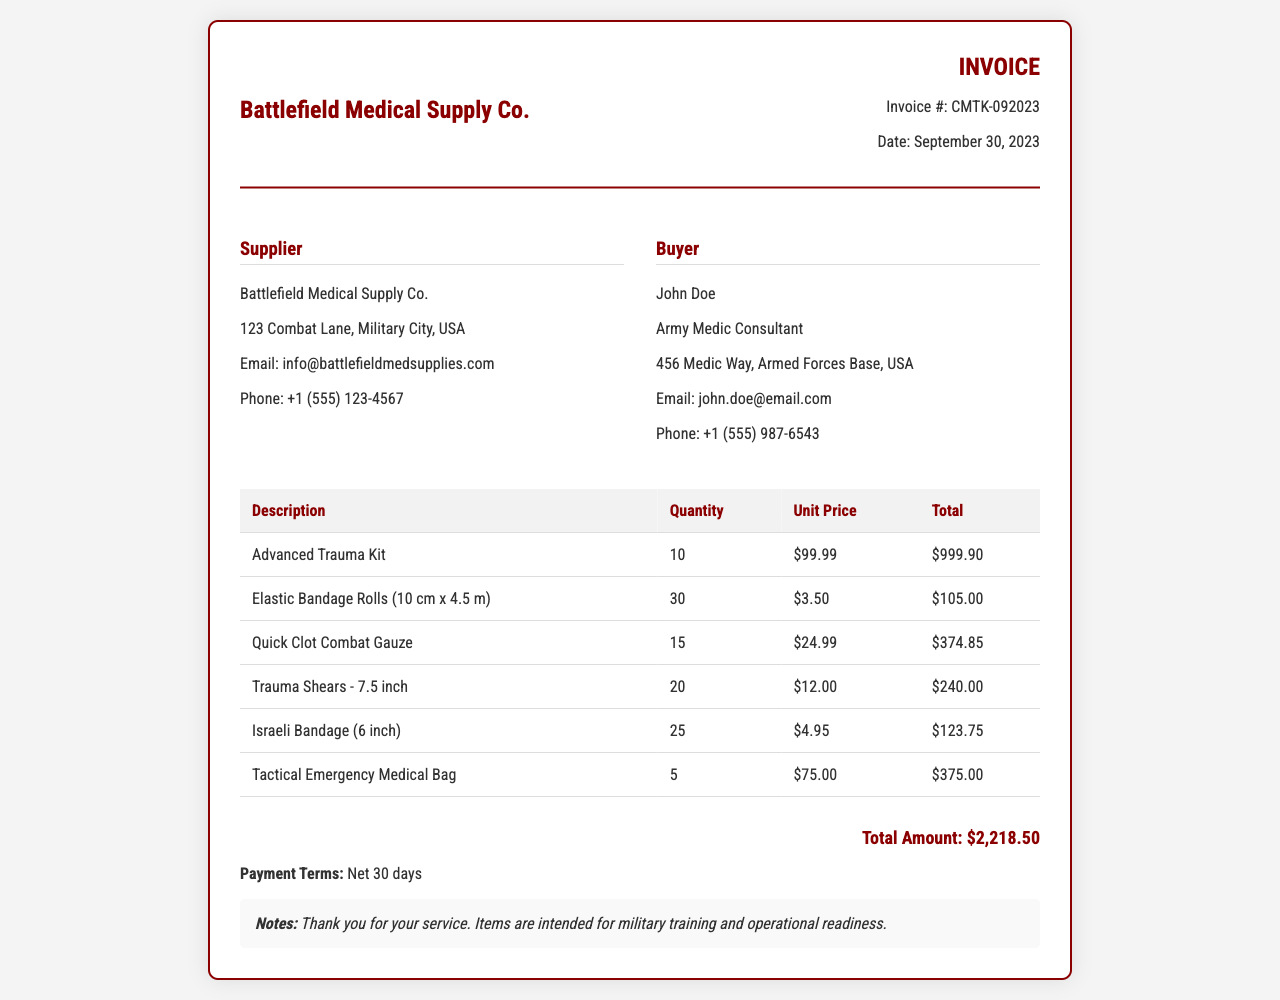What is the invoice number? The invoice number is provided in the document as a unique identifier for the invoice.
Answer: CMTK-092023 What is the date of the invoice? The date is specifically mentioned in the document to indicate when the invoice was generated.
Answer: September 30, 2023 Who is the supplier? The document lists the supplier's name in the "Supplier" section for identification purposes.
Answer: Battlefield Medical Supply Co How many Advanced Trauma Kits were ordered? The quantity is noted in the table under the "Quantity" column for the specific item.
Answer: 10 What is the total amount due on the invoice? The total amount is clearly mentioned at the bottom of the invoice as the final sum of all items.
Answer: $2,218.50 What payment terms are specified? The document outlines payment expectations after the invoice date in a specific section.
Answer: Net 30 days How many Tactical Emergency Medical Bags were purchased? The quantity purchased is given in the invoice table under the respective item.
Answer: 5 What is the unit price of Quick Clot Combat Gauze? The unit price is listed in the table next to the corresponding item for clarity.
Answer: $24.99 What is the purpose of the items listed in the notes section? The purpose is outlined in the notes specifically for clarity on item usage.
Answer: Military training and operational readiness 